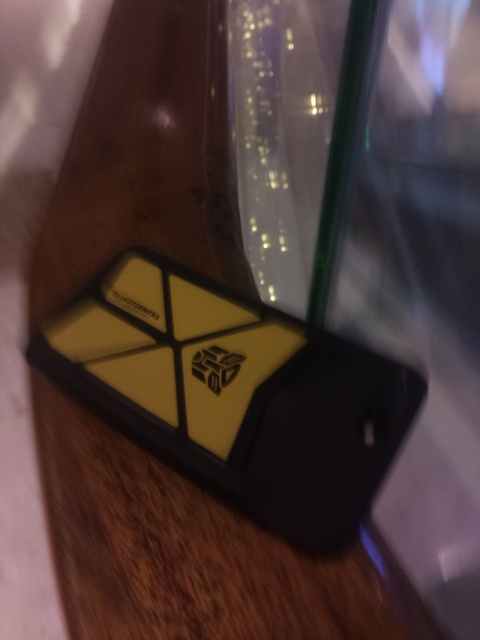Is there any indication of the surrounding environment or the setting where the photo was taken? The surroundings are difficult to identify due to the focus on the phone case and the resulting blur. However, the presence of a reflective surface and diffused lighting suggests an indoor setting, potentially a public place like a café or a lounge due to the presence of a glass which hints at beverage consumption. 